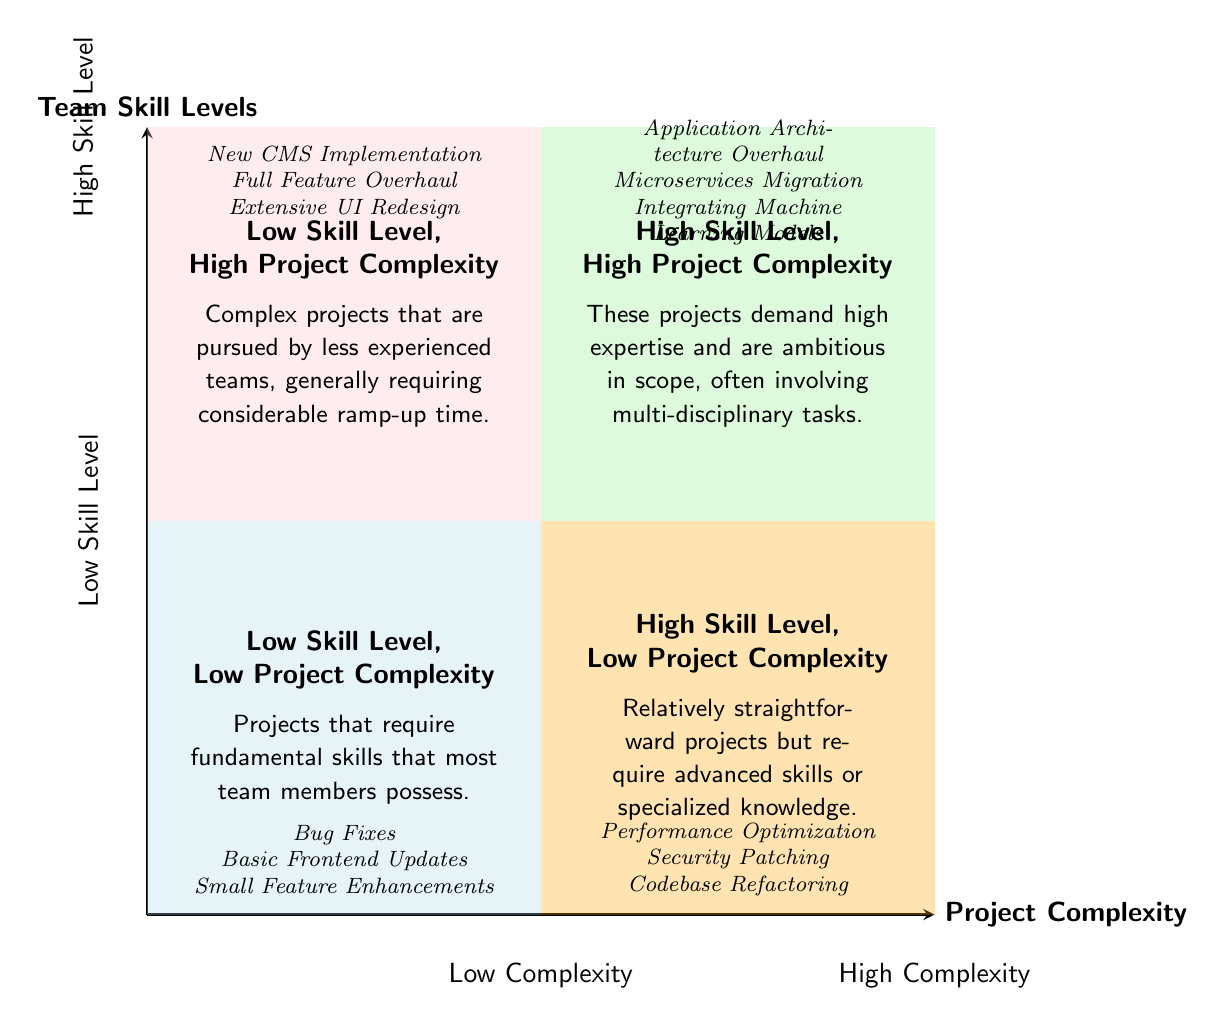What are the projects listed in the "Low Skill Level, Low Project Complexity" quadrant? The quadrant indicates projects that require fundamental skills and examples include Bug Fixes, Basic Frontend Updates, and Small Feature Enhancements. Thus, the answer requires extracting the examples directly from this quadrant.
Answer: Bug Fixes, Basic Frontend Updates, Small Feature Enhancements Which quadrant represents projects that demand high expertise? The quadrant labeled "High Skill Level, High Project Complexity" clearly indicates projects that require high expertise. This is inferred directly from the quadrant's title.
Answer: High Skill Level, High Project Complexity How many quadrants are there in total? The diagram is divided into four distinct quadrants, each representing a different combination of skill level and project complexity. Counting the quadrants gives the answer.
Answer: Four What describes the nature of projects in the "Low Skill Level, High Project Complexity" quadrant? This quadrant details that projects are complex and often tackled by less experienced teams, which indicates a challenge. Thus, it requires connecting this information to the description provided in this quadrant.
Answer: Complex projects pursued by less experienced teams Which quadrant contains "Application Architecture Overhaul"? The example "Application Architecture Overhaul" is listed under the "High Skill Level, High Project Complexity" quadrant, as indicated clearly by the placement of this example in the diagram.
Answer: High Skill Level, High Project Complexity In which quadrant do you find projects that require advanced skills but are low in complexity? The "High Skill Level, Low Project Complexity" quadrant contains such projects, indicated directly by its quadrant label. Thus, evaluating the quadrant titles leads to this answer.
Answer: High Skill Level, Low Project Complexity What type of projects require considerable ramp-up time according to the diagram? The "Low Skill Level, High Project Complexity" quadrant describes that projects in this category generally require considerable ramp-up time, making it an inference from the information provided there.
Answer: Complex projects that are pursued by less experienced teams Name a project example from the "High Skill Level, Low Project Complexity" quadrant. The examples listed in the "High Skill Level, Low Project Complexity" quadrant include Performance Optimization, Security Patching, and Codebase Refactoring. Therefore, any of these can be a valid answer.
Answer: Performance Optimization 